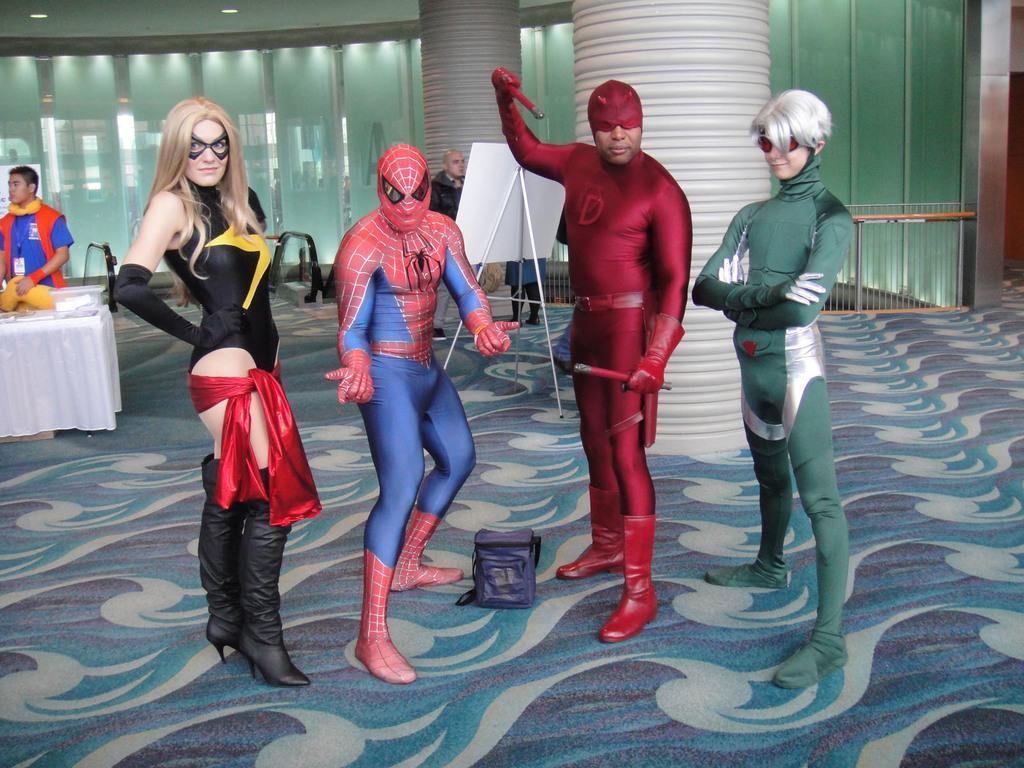How would you summarize this image in a sentence or two? In this image, we can see some people wearing fancy dresses, there is a table covered with white cloth, there is a man standing, we can see the pillars and there is a carpet on the floor. 